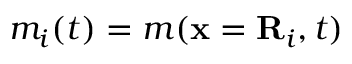Convert formula to latex. <formula><loc_0><loc_0><loc_500><loc_500>m _ { i } ( t ) = m ( x = R _ { i } , t )</formula> 